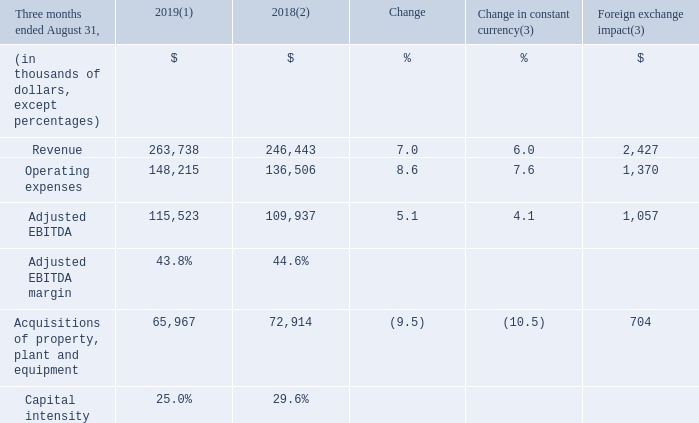(1) For the three-month period ended August 31, 2019, the average foreign exchange rate used for translation was 1.3222 USD/CDN. (2) Fiscal 2018 was restated to comply with IFRS 15 and to reflect a change in accounting policy. For further details, please consult the "Accounting policies" section. (3) Fiscal 2019 actuals are translated at the average foreign exchange rate of the comparable period of fiscal 2018 which was 1.3100 USD/CDN.
REVENUE Fiscal 2019 fourth-quarter revenue increased by 7.0% (6.0% in constant currency). In local currency, revenue amounted to US$199.5 million compared to US$188.1 million for the same period of fiscal 2018. The increase resulted mainly from: • rate increases; • activation of bulk properties in Florida during the fourth quarter of fiscal 2019; • continued growth in Internet service customers; and • the FiberLight acquisition completed in the first quarter of fiscal 2019; partly offset by • a decrease in video service customers.
OPERATING EXPENSES Fiscal 2019 fourth-quarter operating expenses increased by 8.6% (7.6% in constant currency) mainly as a result of: • programming rate increases; • the FiberLight acquisition completed in the first quarter of fiscal 2019; • higher compensation expenses due to higher headcount to support growth; and • higher marketing initiatives to drive primary service units growth.
ADJUSTED EBITDA Fiscal 2019 fourth-quarter adjusted EBITDA increased by 5.1% (4.1% in constant currency). In local currency, adjusted EBITDA amounted to US$87.4 million compared to US$83.9 million for the same period of fiscal 2018. The increase was mainly due to organic growth combined with the impact of the FiberLight acquisition.
ACQUISITIONS OF PROPERTY, PLANT AND EQUIPMENT Fiscal 2019 fourth-quarter acquisitions of property, plant and equipment decreased by 9.5% (10.5% in constant currency) mainly due to: • lower purchases of customer premise equipment due to the timing of certain initiatives; and • lower capital expenditures due to the timing of certain initiatives; partly offset by • additional capital expenditures related to the expansion in Florida.
What was the exchange rate in 2019? 1.3222 usd/cdn. What was the exchange rate in 2018? 1.3100 usd/cdn. What was the revenue increase in 2019? 7.0%. What was the increase / (decrease) in revenue from 2018 to 2019?
Answer scale should be: thousand. 263,738 - 246,443
Answer: 17295. What was the increase / (decrease) in operating expenses from 2018 to 2019?
Answer scale should be: thousand. 148,215 - 136,506
Answer: 11709. What was the average Adjusted EBITDA?
Answer scale should be: thousand. (115,523 + 109,937) / 2
Answer: 112730. 